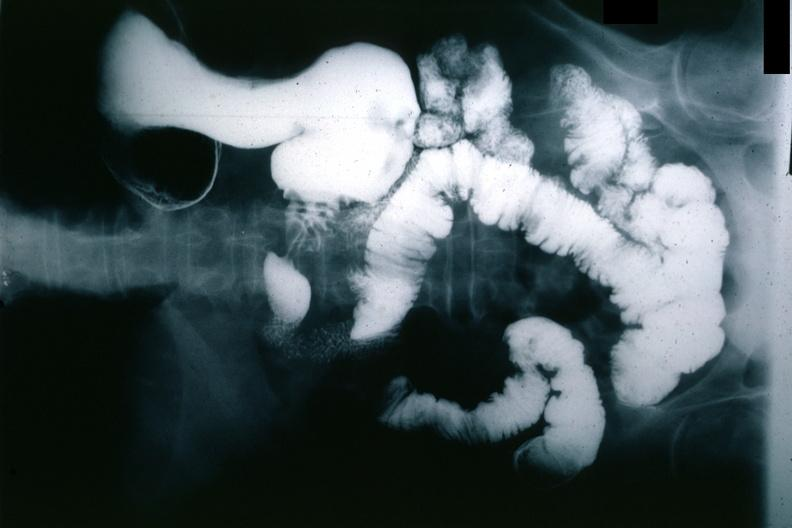does appendix show x-ray barium study gastric polyp?
Answer the question using a single word or phrase. No 